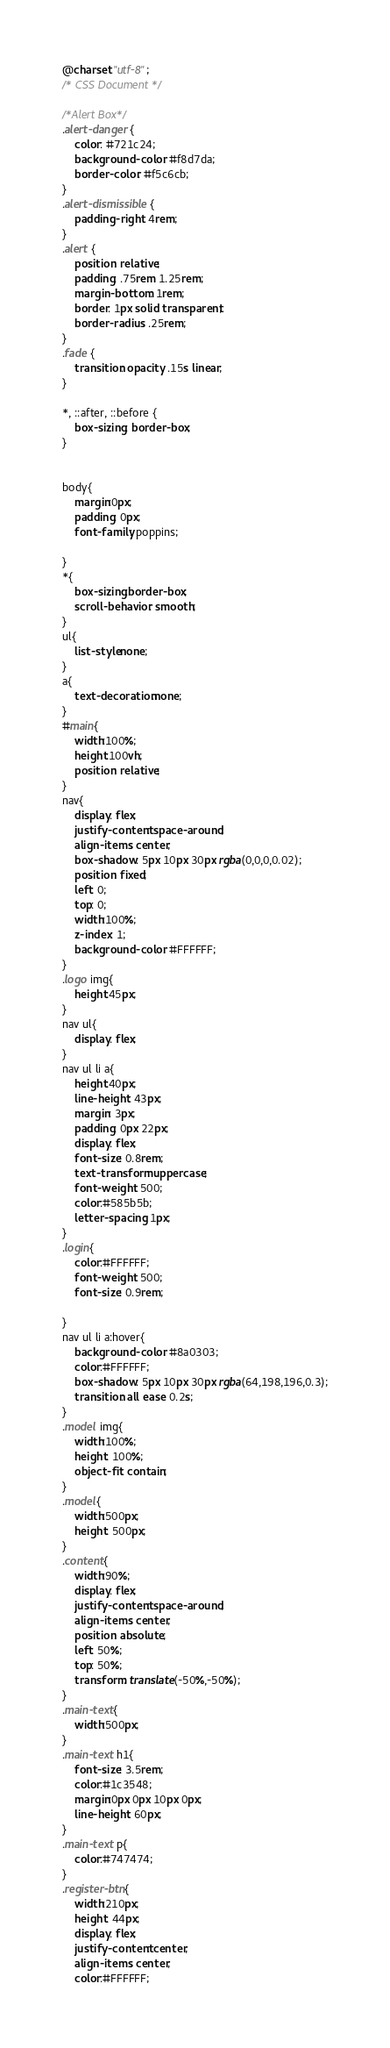Convert code to text. <code><loc_0><loc_0><loc_500><loc_500><_CSS_>@charset "utf-8";
/* CSS Document */

/*Alert Box*/
.alert-danger {
    color: #721c24;
    background-color: #f8d7da;
    border-color: #f5c6cb;
}
.alert-dismissible {
    padding-right: 4rem;
}
.alert {
    position: relative;
    padding: .75rem 1.25rem;
    margin-bottom: 1rem;
    border: 1px solid transparent;
    border-radius: .25rem;
}
.fade {
    transition: opacity .15s linear;
}

*, ::after, ::before {
    box-sizing: border-box;
}


body{
	margin:0px;
	padding: 0px;
	font-family: poppins;

}
*{
	box-sizing:border-box;
	scroll-behavior: smooth;
}
ul{
	list-style:none;
}
a{
	text-decoration:none;
}
#main{
	width:100%;
	height:100vh;
	position: relative;
}
nav{
	display: flex;
	justify-content: space-around;
	align-items: center;
	box-shadow: 5px 10px 30px rgba(0,0,0,0.02);
	position: fixed;
	left: 0;
	top: 0;
	width:100%;
	z-index: 1;
	background-color: #FFFFFF;
}
.logo img{
	height:45px;
}
nav ul{
	display: flex;
}
nav ul li a{
	height:40px;
	line-height: 43px;
	margin: 3px;
	padding: 0px 22px;
	display: flex;
	font-size: 0.8rem;
	text-transform: uppercase;
	font-weight: 500;
	color:#585b5b;
	letter-spacing: 1px;
}
.login{
	color:#FFFFFF;
	font-weight: 500;
	font-size: 0.9rem;

}
nav ul li a:hover{
	background-color: #8a0303;
	color:#FFFFFF;
	box-shadow: 5px 10px 30px rgba(64,198,196,0.3);
	transition: all ease 0.2s;
}
.model img{
	width:100%;
	height: 100%;
	object-fit: contain;
}
.model{
	width:500px;
	height: 500px;
}
.content{
	width:90%;
	display: flex;
	justify-content: space-around;
	align-items: center;
	position: absolute;
	left: 50%;
	top: 50%;
	transform: translate(-50%,-50%);
}
.main-text{
	width:500px;
}
.main-text h1{
	font-size: 3.5rem;
	color:#1c3548;
	margin:0px 0px 10px 0px;
	line-height: 60px;
}
.main-text p{
	color:#747474;
}
.register-btn{
	width:210px;
	height: 44px;
	display: flex;
	justify-content: center;
	align-items: center;
	color:#FFFFFF;</code> 